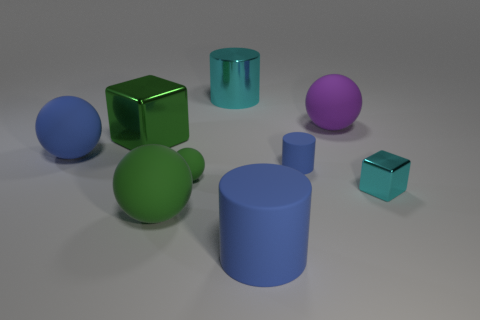What color is the metallic block that is in front of the big rubber thing to the left of the large green object that is behind the small blue matte cylinder?
Provide a short and direct response. Cyan. What number of blocks are yellow metal things or tiny blue matte objects?
Provide a succinct answer. 0. There is a big block that is the same color as the small matte sphere; what is it made of?
Your answer should be very brief. Metal. There is a large cube; is it the same color as the tiny rubber ball that is in front of the shiny cylinder?
Offer a terse response. Yes. What color is the tiny metal object?
Offer a terse response. Cyan. What number of objects are small yellow spheres or green metal cubes?
Make the answer very short. 1. There is a green cube that is the same size as the blue matte sphere; what material is it?
Your answer should be compact. Metal. How big is the green rubber object on the right side of the big green rubber object?
Your answer should be compact. Small. What material is the large cyan cylinder?
Give a very brief answer. Metal. What number of objects are large matte spheres behind the big green cube or blue rubber objects that are behind the small cyan metallic cube?
Provide a succinct answer. 3. 